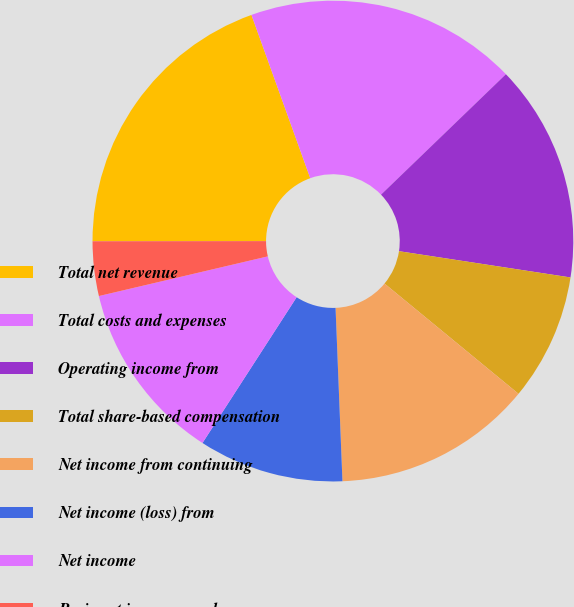Convert chart to OTSL. <chart><loc_0><loc_0><loc_500><loc_500><pie_chart><fcel>Total net revenue<fcel>Total costs and expenses<fcel>Operating income from<fcel>Total share-based compensation<fcel>Net income from continuing<fcel>Net income (loss) from<fcel>Net income<fcel>Basic net income per share<fcel>Basic net income (loss) per<nl><fcel>19.51%<fcel>18.29%<fcel>14.63%<fcel>8.54%<fcel>13.41%<fcel>9.76%<fcel>12.2%<fcel>3.66%<fcel>0.0%<nl></chart> 